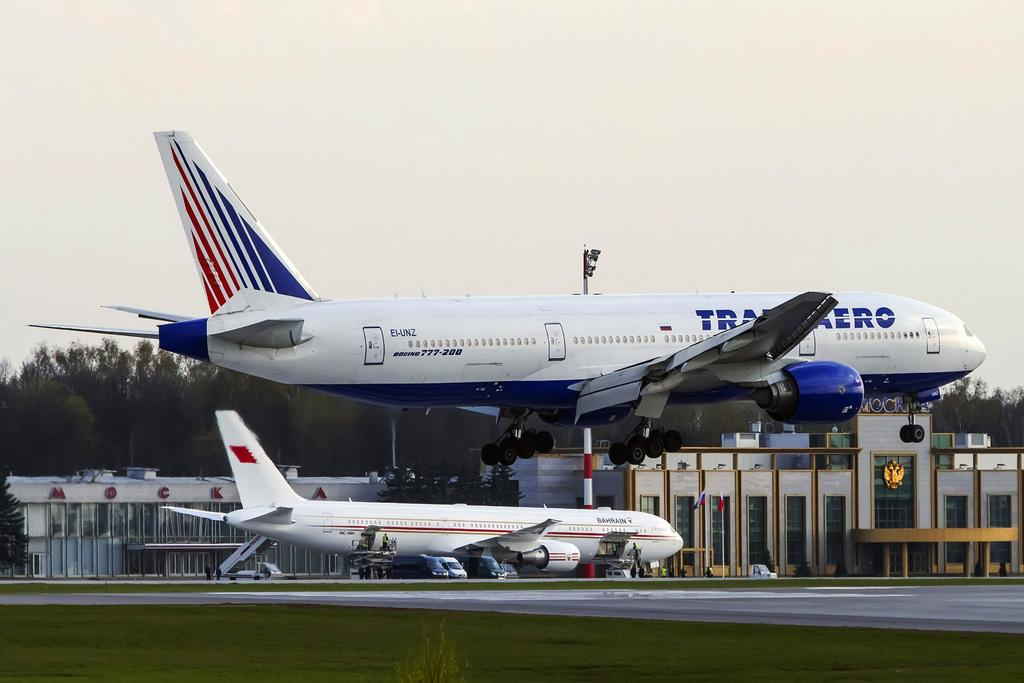<image>
Give a short and clear explanation of the subsequent image. The large plane with the red and blue stripes is a Boeing 777-200. 